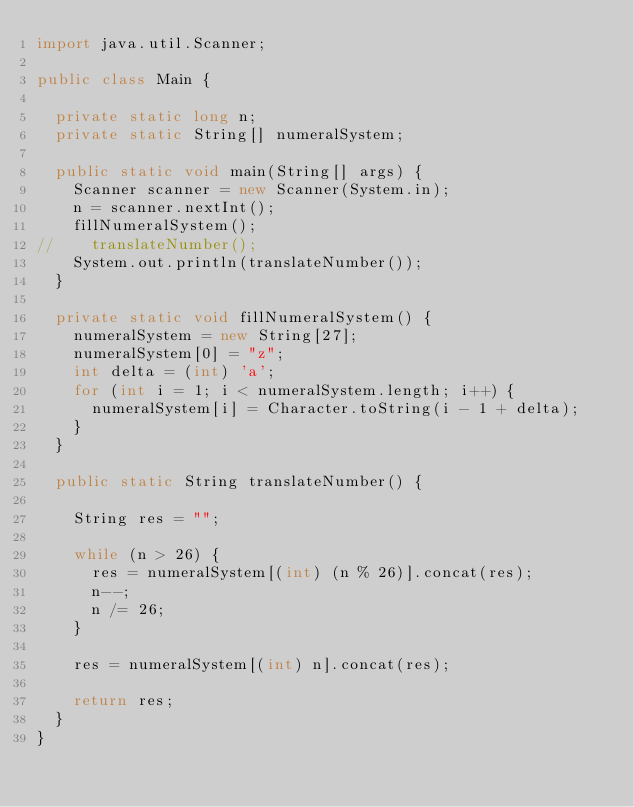<code> <loc_0><loc_0><loc_500><loc_500><_Java_>import java.util.Scanner;

public class Main {

	private static long n;
	private static String[] numeralSystem;

	public static void main(String[] args) {
		Scanner scanner = new Scanner(System.in);
		n = scanner.nextInt();
		fillNumeralSystem();
//		translateNumber();
		System.out.println(translateNumber());
	}

	private static void fillNumeralSystem() {
		numeralSystem = new String[27];
		numeralSystem[0] = "z";
		int delta = (int) 'a';
		for (int i = 1; i < numeralSystem.length; i++) {
			numeralSystem[i] = Character.toString(i - 1 + delta);
		}
	}

	public static String translateNumber() {

		String res = "";

		while (n > 26) {
			res = numeralSystem[(int) (n % 26)].concat(res);
			n--;
			n /= 26;
		}

		res = numeralSystem[(int) n].concat(res);

		return res;
	}
}</code> 